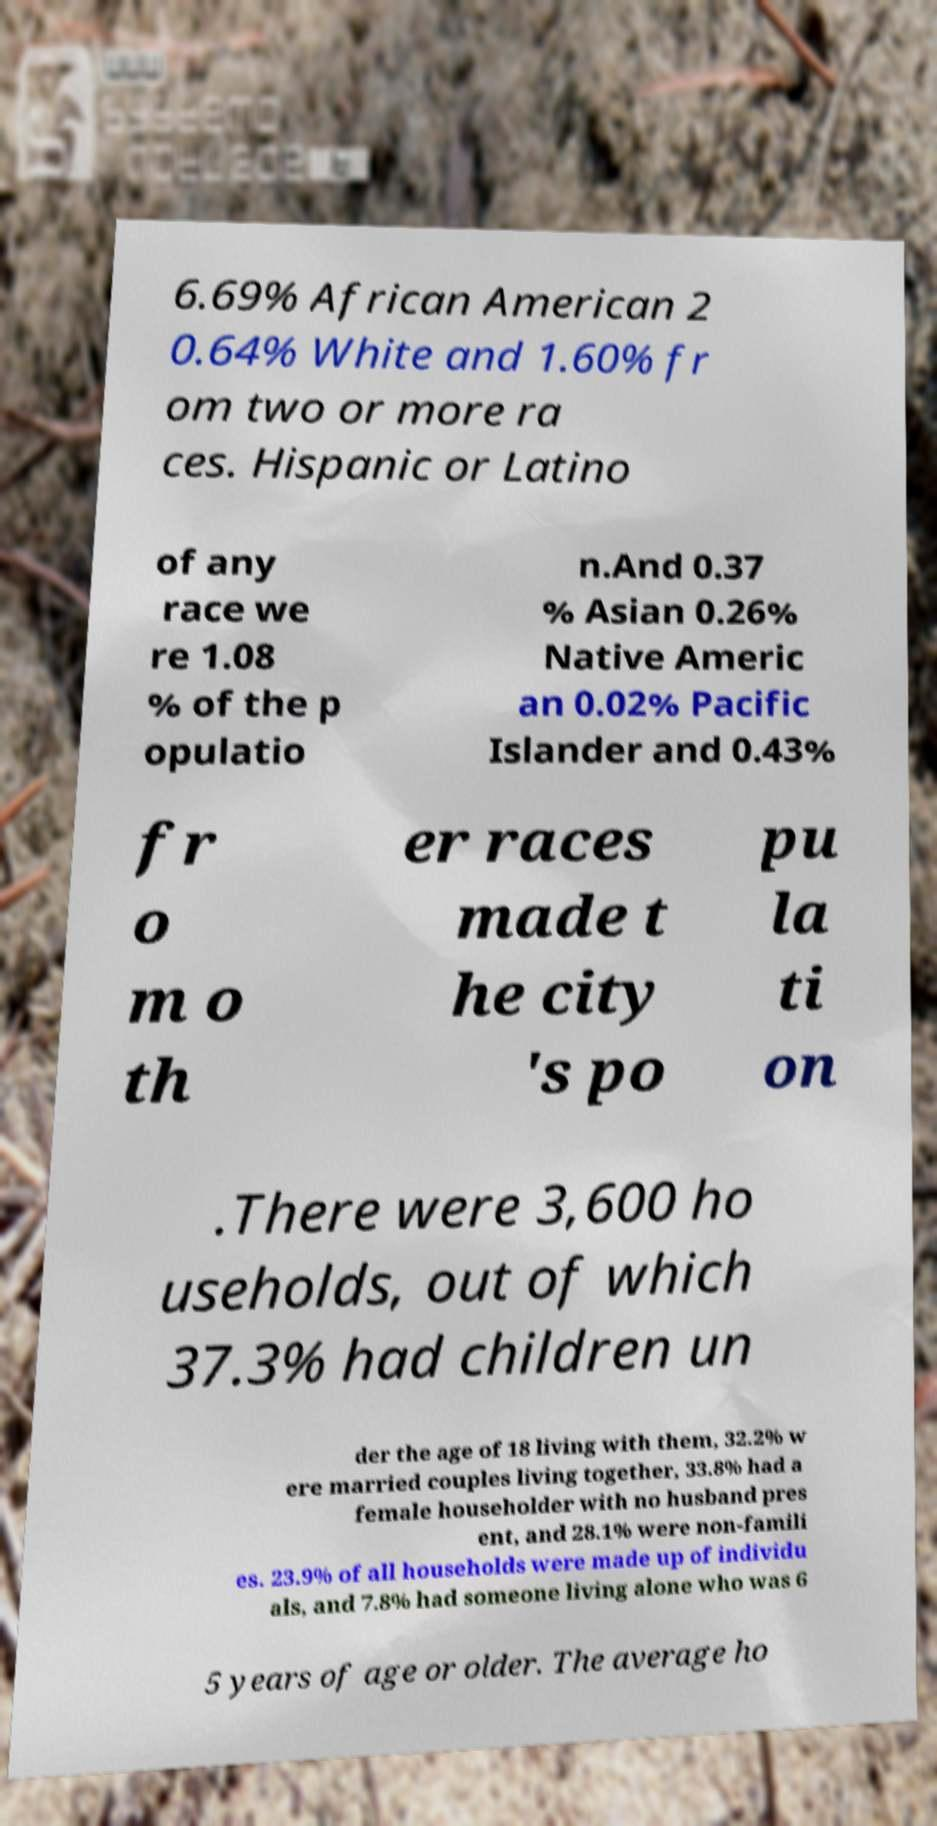Could you extract and type out the text from this image? 6.69% African American 2 0.64% White and 1.60% fr om two or more ra ces. Hispanic or Latino of any race we re 1.08 % of the p opulatio n.And 0.37 % Asian 0.26% Native Americ an 0.02% Pacific Islander and 0.43% fr o m o th er races made t he city 's po pu la ti on .There were 3,600 ho useholds, out of which 37.3% had children un der the age of 18 living with them, 32.2% w ere married couples living together, 33.8% had a female householder with no husband pres ent, and 28.1% were non-famili es. 23.9% of all households were made up of individu als, and 7.8% had someone living alone who was 6 5 years of age or older. The average ho 